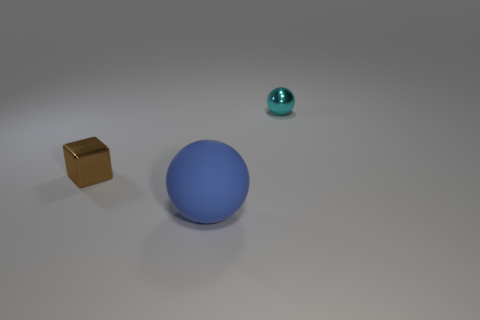Add 3 large green metallic spheres. How many objects exist? 6 Subtract all balls. How many objects are left? 1 Add 2 blue balls. How many blue balls are left? 3 Add 1 blue things. How many blue things exist? 2 Subtract 0 gray spheres. How many objects are left? 3 Subtract all red cubes. Subtract all cyan balls. How many cubes are left? 1 Subtract all blue objects. Subtract all cyan objects. How many objects are left? 1 